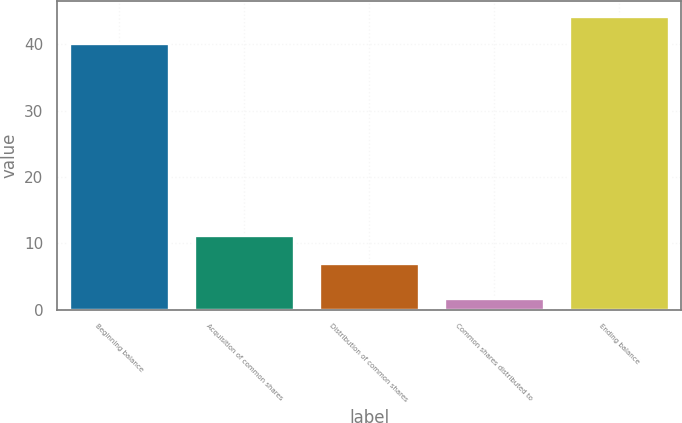<chart> <loc_0><loc_0><loc_500><loc_500><bar_chart><fcel>Beginning balance<fcel>Acquisition of common shares<fcel>Distribution of common shares<fcel>Common shares distributed to<fcel>Ending balance<nl><fcel>40.2<fcel>11.3<fcel>7<fcel>1.8<fcel>44.29<nl></chart> 